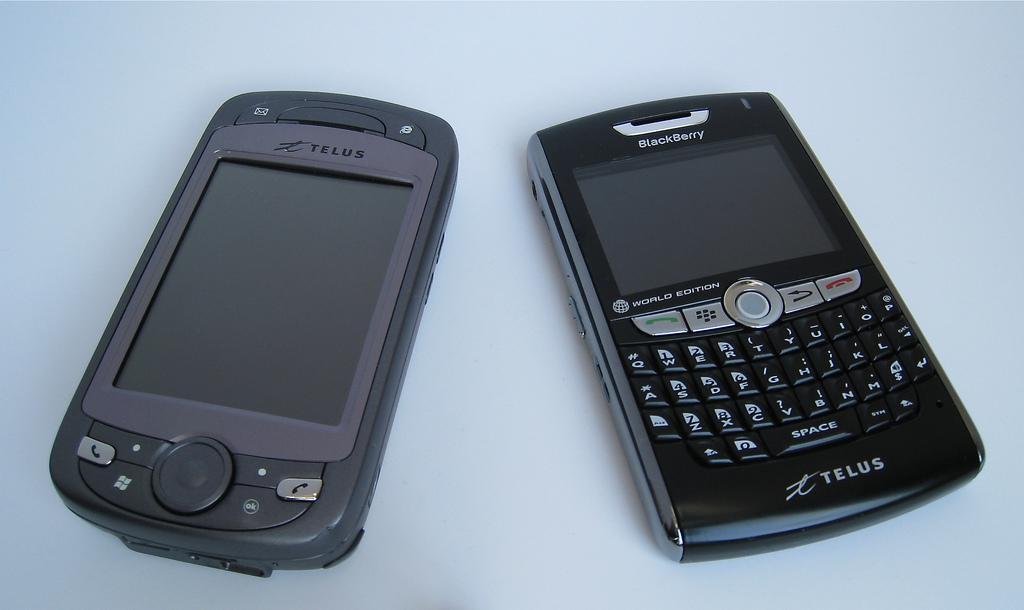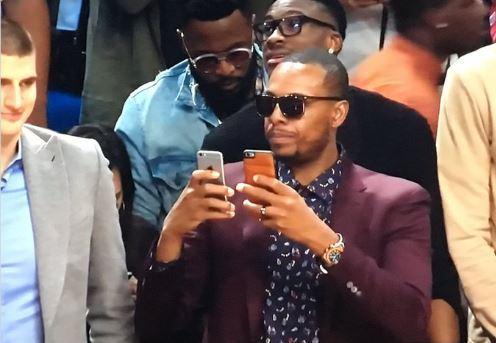The first image is the image on the left, the second image is the image on the right. Examine the images to the left and right. Is the description "A person is holding two phones in the right image." accurate? Answer yes or no. Yes. The first image is the image on the left, the second image is the image on the right. Examine the images to the left and right. Is the description "Three or more humans are visible." accurate? Answer yes or no. Yes. 